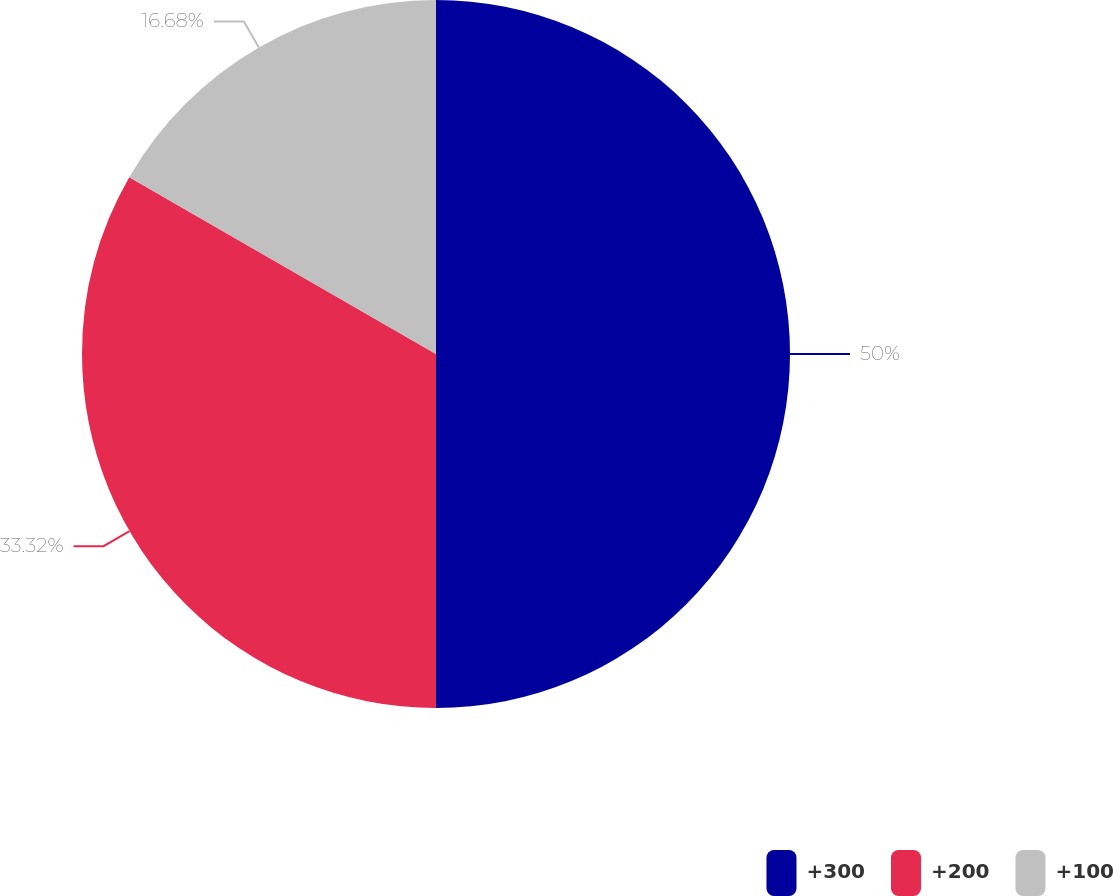Convert chart to OTSL. <chart><loc_0><loc_0><loc_500><loc_500><pie_chart><fcel>+300<fcel>+200<fcel>+100<nl><fcel>50.0%<fcel>33.32%<fcel>16.68%<nl></chart> 